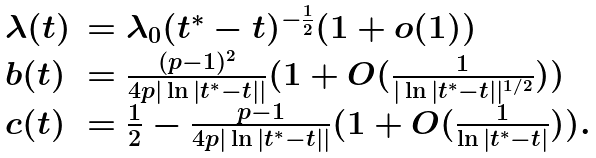<formula> <loc_0><loc_0><loc_500><loc_500>\begin{array} { l l l } \lambda ( t ) & = \lambda _ { 0 } ( t ^ { * } - t ) ^ { - \frac { 1 } { 2 } } ( 1 + o ( 1 ) ) \\ b ( t ) & = \frac { ( p - 1 ) ^ { 2 } } { 4 p | \ln | t ^ { * } - t | | } ( 1 + O ( \frac { 1 } { | \ln | t ^ { * } - t | | ^ { 1 / 2 } } ) ) \\ c ( t ) & = \frac { 1 } { 2 } - \frac { p - 1 } { 4 p | \ln | t ^ { * } - t | | } ( 1 + O ( \frac { 1 } { \ln | t ^ { * } - t | } ) ) . \end{array}</formula> 